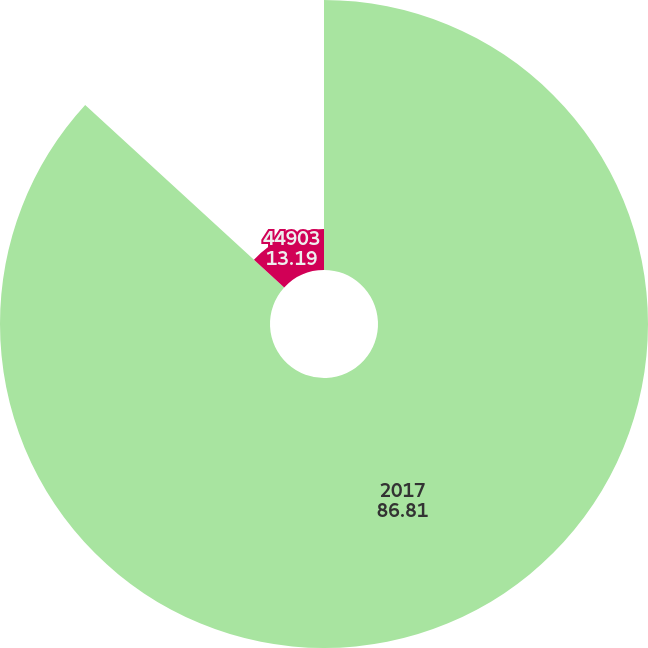Convert chart to OTSL. <chart><loc_0><loc_0><loc_500><loc_500><pie_chart><fcel>2017<fcel>44903<nl><fcel>86.81%<fcel>13.19%<nl></chart> 